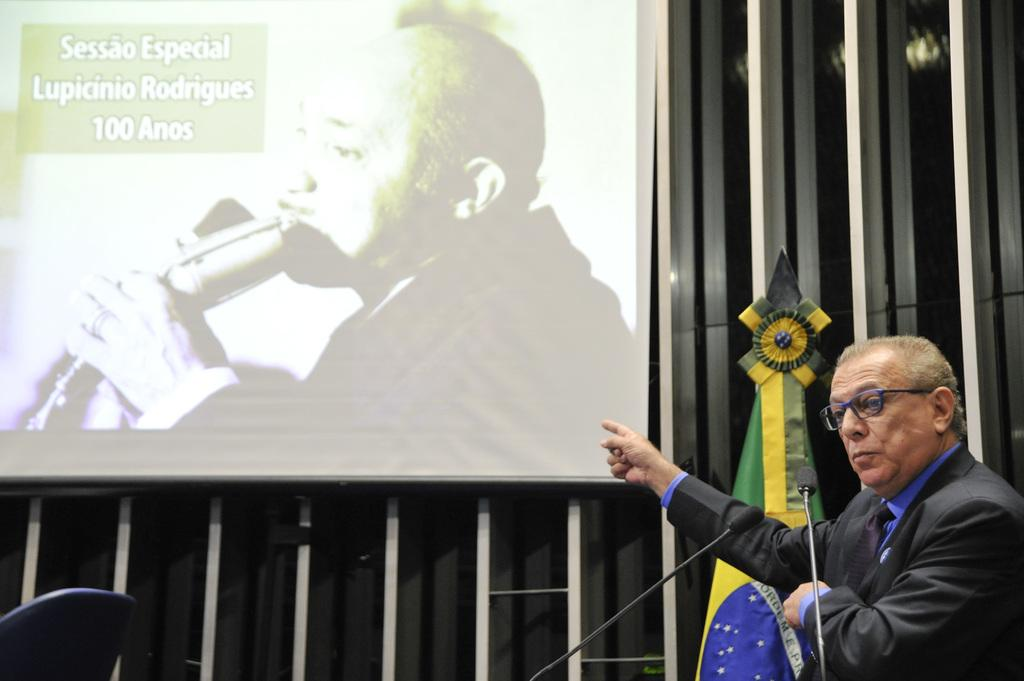What can be seen in the image? There is a person in the image. Can you describe the person's attire? The person is wearing a dress with purple and black colors. What accessory is the person wearing? The person is wearing specs. What object is in front of the person? There is a microphone in front of the person. What can be seen in the background of the image? There is a flag and a screen in the background of the image. What type of scent can be detected from the person in the image? There is no information about the person's scent in the image, so it cannot be determined. Is there a crook present in the image? There is no crook present in the image. Can you see a yak in the image? There is no yak present in the image. 